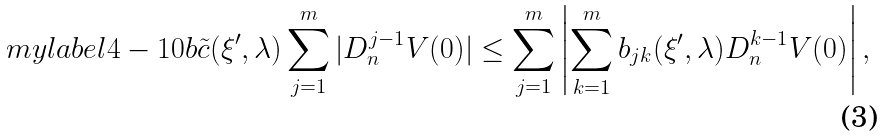<formula> <loc_0><loc_0><loc_500><loc_500>\ m y l a b e l { 4 - 1 0 b } \tilde { c } ( \xi ^ { \prime } , \lambda ) \sum _ { j = 1 } ^ { m } | D _ { n } ^ { j - 1 } V ( 0 ) | \leq \sum _ { j = 1 } ^ { m } \left | \sum _ { k = 1 } ^ { m } b _ { j k } ( \xi ^ { \prime } , \lambda ) D _ { n } ^ { k - 1 } V ( 0 ) \right | ,</formula> 